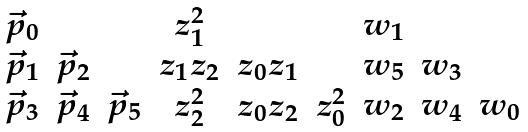<formula> <loc_0><loc_0><loc_500><loc_500>\begin{array} { c c c } \vec { p } _ { 0 } & & \\ \vec { p } _ { 1 } & \vec { p } _ { 2 } & \\ \vec { p } _ { 3 } & \vec { p } _ { 4 } & \vec { p } _ { 5 } \end{array} \begin{array} { c c c } z _ { 1 } ^ { 2 } & & \\ z _ { 1 } z _ { 2 } & z _ { 0 } z _ { 1 } & \\ z _ { 2 } ^ { 2 } & z _ { 0 } z _ { 2 } & z _ { 0 } ^ { 2 } \end{array} \begin{array} { c c c } w _ { 1 } & & \\ w _ { 5 } & w _ { 3 } & \\ w _ { 2 } & w _ { 4 } & w _ { 0 } \end{array}</formula> 